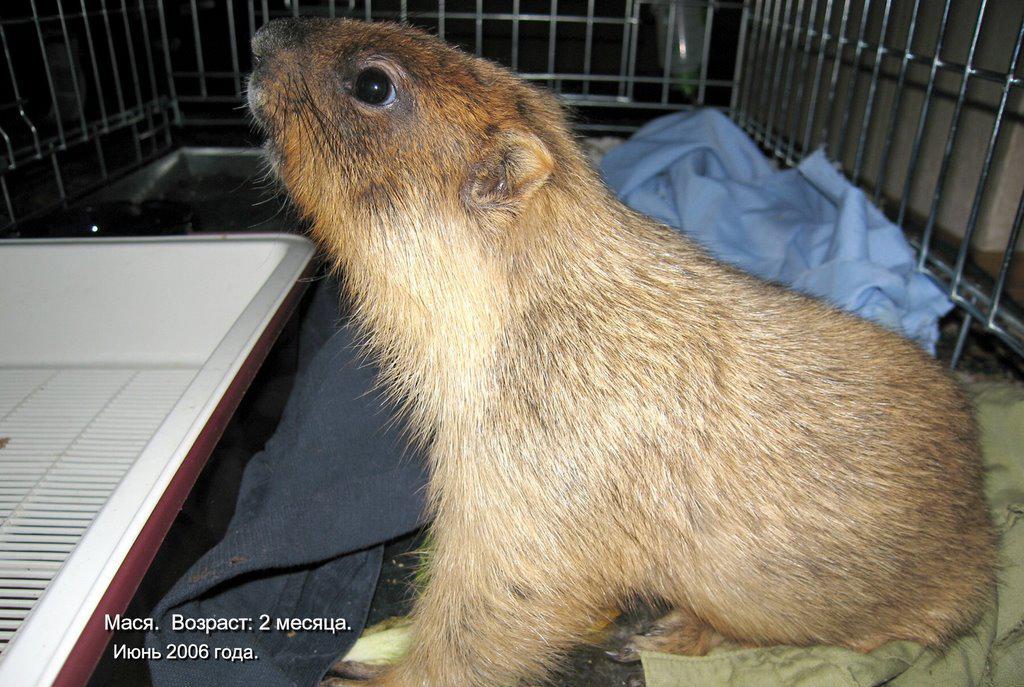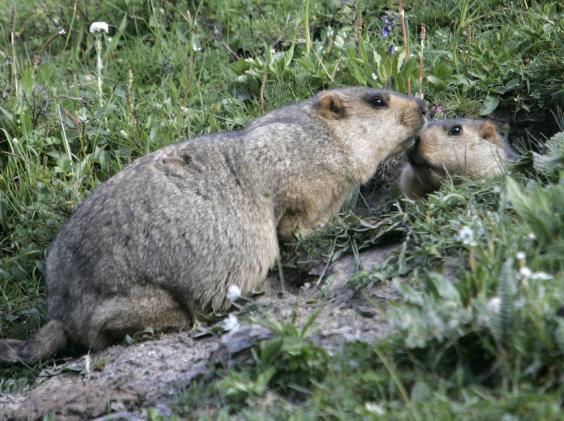The first image is the image on the left, the second image is the image on the right. Analyze the images presented: Is the assertion "There is at least one animal standing on its hind legs holding something in its front paws." valid? Answer yes or no. No. The first image is the image on the left, the second image is the image on the right. Considering the images on both sides, is "An image contains at least twice as many marmots as the other image." valid? Answer yes or no. Yes. 